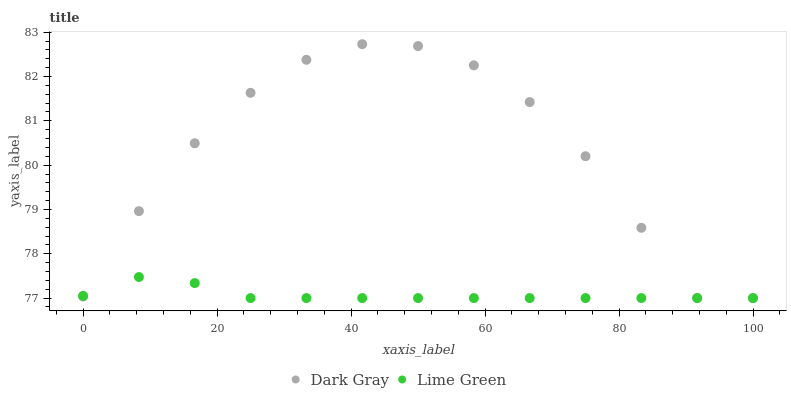Does Lime Green have the minimum area under the curve?
Answer yes or no. Yes. Does Dark Gray have the maximum area under the curve?
Answer yes or no. Yes. Does Lime Green have the maximum area under the curve?
Answer yes or no. No. Is Lime Green the smoothest?
Answer yes or no. Yes. Is Dark Gray the roughest?
Answer yes or no. Yes. Is Lime Green the roughest?
Answer yes or no. No. Does Dark Gray have the lowest value?
Answer yes or no. Yes. Does Dark Gray have the highest value?
Answer yes or no. Yes. Does Lime Green have the highest value?
Answer yes or no. No. Does Dark Gray intersect Lime Green?
Answer yes or no. Yes. Is Dark Gray less than Lime Green?
Answer yes or no. No. Is Dark Gray greater than Lime Green?
Answer yes or no. No. 